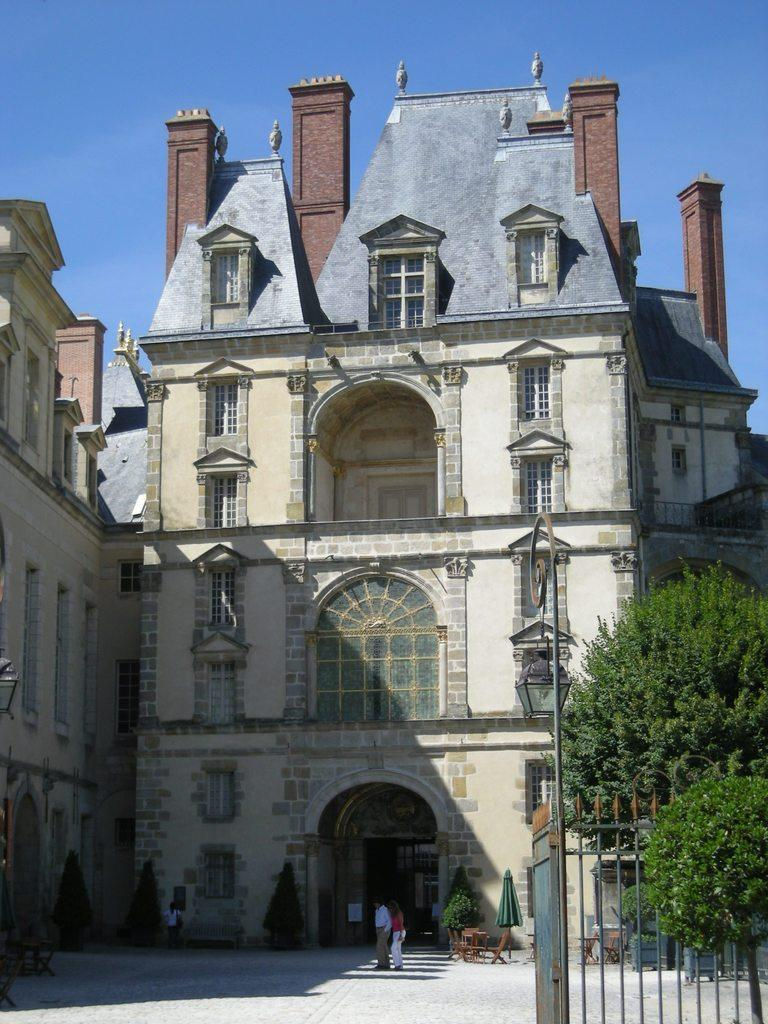What type of structures can be seen in the image? There are buildings with windows in the image. What type of barrier is present in the image? There is a metal fence in the image. What type of natural elements are present in the image? There are trees and plants in the image. Are there any living beings in the image? Yes, there are people in the image. What can be seen in the background of the image? The sky is visible in the background of the image. What type of fruit is being harvested by the people in the image? There is no fruit being harvested in the image; the people are not depicted performing any such activity. 